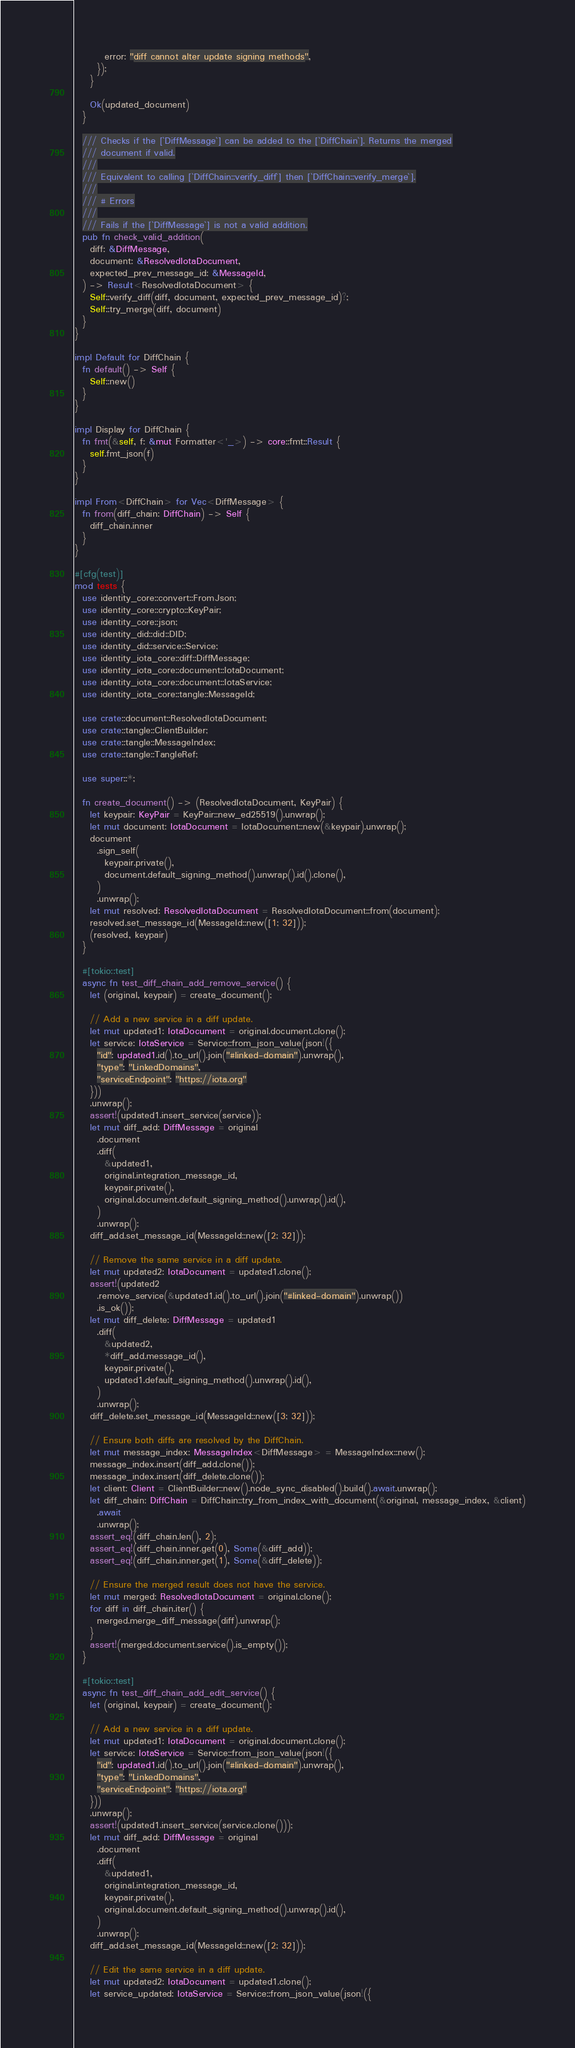<code> <loc_0><loc_0><loc_500><loc_500><_Rust_>        error: "diff cannot alter update signing methods",
      });
    }

    Ok(updated_document)
  }

  /// Checks if the [`DiffMessage`] can be added to the [`DiffChain`]. Returns the merged
  /// document if valid.
  ///
  /// Equivalent to calling [`DiffChain::verify_diff`] then [`DiffChain::verify_merge`].
  ///
  /// # Errors
  ///
  /// Fails if the [`DiffMessage`] is not a valid addition.
  pub fn check_valid_addition(
    diff: &DiffMessage,
    document: &ResolvedIotaDocument,
    expected_prev_message_id: &MessageId,
  ) -> Result<ResolvedIotaDocument> {
    Self::verify_diff(diff, document, expected_prev_message_id)?;
    Self::try_merge(diff, document)
  }
}

impl Default for DiffChain {
  fn default() -> Self {
    Self::new()
  }
}

impl Display for DiffChain {
  fn fmt(&self, f: &mut Formatter<'_>) -> core::fmt::Result {
    self.fmt_json(f)
  }
}

impl From<DiffChain> for Vec<DiffMessage> {
  fn from(diff_chain: DiffChain) -> Self {
    diff_chain.inner
  }
}

#[cfg(test)]
mod tests {
  use identity_core::convert::FromJson;
  use identity_core::crypto::KeyPair;
  use identity_core::json;
  use identity_did::did::DID;
  use identity_did::service::Service;
  use identity_iota_core::diff::DiffMessage;
  use identity_iota_core::document::IotaDocument;
  use identity_iota_core::document::IotaService;
  use identity_iota_core::tangle::MessageId;

  use crate::document::ResolvedIotaDocument;
  use crate::tangle::ClientBuilder;
  use crate::tangle::MessageIndex;
  use crate::tangle::TangleRef;

  use super::*;

  fn create_document() -> (ResolvedIotaDocument, KeyPair) {
    let keypair: KeyPair = KeyPair::new_ed25519().unwrap();
    let mut document: IotaDocument = IotaDocument::new(&keypair).unwrap();
    document
      .sign_self(
        keypair.private(),
        document.default_signing_method().unwrap().id().clone(),
      )
      .unwrap();
    let mut resolved: ResolvedIotaDocument = ResolvedIotaDocument::from(document);
    resolved.set_message_id(MessageId::new([1; 32]));
    (resolved, keypair)
  }

  #[tokio::test]
  async fn test_diff_chain_add_remove_service() {
    let (original, keypair) = create_document();

    // Add a new service in a diff update.
    let mut updated1: IotaDocument = original.document.clone();
    let service: IotaService = Service::from_json_value(json!({
      "id": updated1.id().to_url().join("#linked-domain").unwrap(),
      "type": "LinkedDomains",
      "serviceEndpoint": "https://iota.org"
    }))
    .unwrap();
    assert!(updated1.insert_service(service));
    let mut diff_add: DiffMessage = original
      .document
      .diff(
        &updated1,
        original.integration_message_id,
        keypair.private(),
        original.document.default_signing_method().unwrap().id(),
      )
      .unwrap();
    diff_add.set_message_id(MessageId::new([2; 32]));

    // Remove the same service in a diff update.
    let mut updated2: IotaDocument = updated1.clone();
    assert!(updated2
      .remove_service(&updated1.id().to_url().join("#linked-domain").unwrap())
      .is_ok());
    let mut diff_delete: DiffMessage = updated1
      .diff(
        &updated2,
        *diff_add.message_id(),
        keypair.private(),
        updated1.default_signing_method().unwrap().id(),
      )
      .unwrap();
    diff_delete.set_message_id(MessageId::new([3; 32]));

    // Ensure both diffs are resolved by the DiffChain.
    let mut message_index: MessageIndex<DiffMessage> = MessageIndex::new();
    message_index.insert(diff_add.clone());
    message_index.insert(diff_delete.clone());
    let client: Client = ClientBuilder::new().node_sync_disabled().build().await.unwrap();
    let diff_chain: DiffChain = DiffChain::try_from_index_with_document(&original, message_index, &client)
      .await
      .unwrap();
    assert_eq!(diff_chain.len(), 2);
    assert_eq!(diff_chain.inner.get(0), Some(&diff_add));
    assert_eq!(diff_chain.inner.get(1), Some(&diff_delete));

    // Ensure the merged result does not have the service.
    let mut merged: ResolvedIotaDocument = original.clone();
    for diff in diff_chain.iter() {
      merged.merge_diff_message(diff).unwrap();
    }
    assert!(merged.document.service().is_empty());
  }

  #[tokio::test]
  async fn test_diff_chain_add_edit_service() {
    let (original, keypair) = create_document();

    // Add a new service in a diff update.
    let mut updated1: IotaDocument = original.document.clone();
    let service: IotaService = Service::from_json_value(json!({
      "id": updated1.id().to_url().join("#linked-domain").unwrap(),
      "type": "LinkedDomains",
      "serviceEndpoint": "https://iota.org"
    }))
    .unwrap();
    assert!(updated1.insert_service(service.clone()));
    let mut diff_add: DiffMessage = original
      .document
      .diff(
        &updated1,
        original.integration_message_id,
        keypair.private(),
        original.document.default_signing_method().unwrap().id(),
      )
      .unwrap();
    diff_add.set_message_id(MessageId::new([2; 32]));

    // Edit the same service in a diff update.
    let mut updated2: IotaDocument = updated1.clone();
    let service_updated: IotaService = Service::from_json_value(json!({</code> 